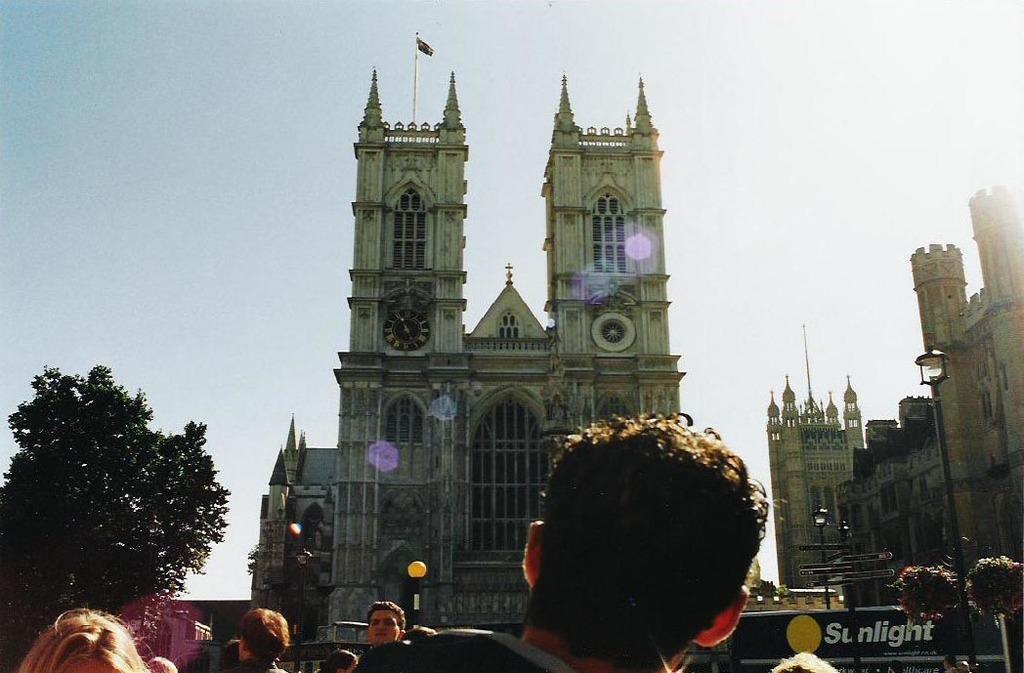Can you describe this image briefly? In the image there are few people visible in the front and behind there are castles and buildings with trees in front of it and above its sky. 